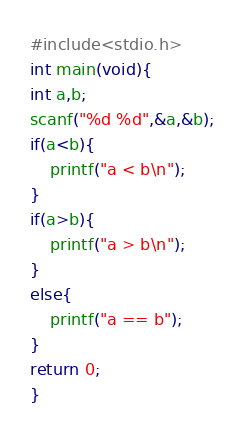<code> <loc_0><loc_0><loc_500><loc_500><_C_>#include<stdio.h>
int main(void){
int a,b;
scanf("%d %d",&a,&b);
if(a<b){
	printf("a < b\n");
}
if(a>b){
	printf("a > b\n");
}
else{
	printf("a == b");
}
return 0;
}</code> 